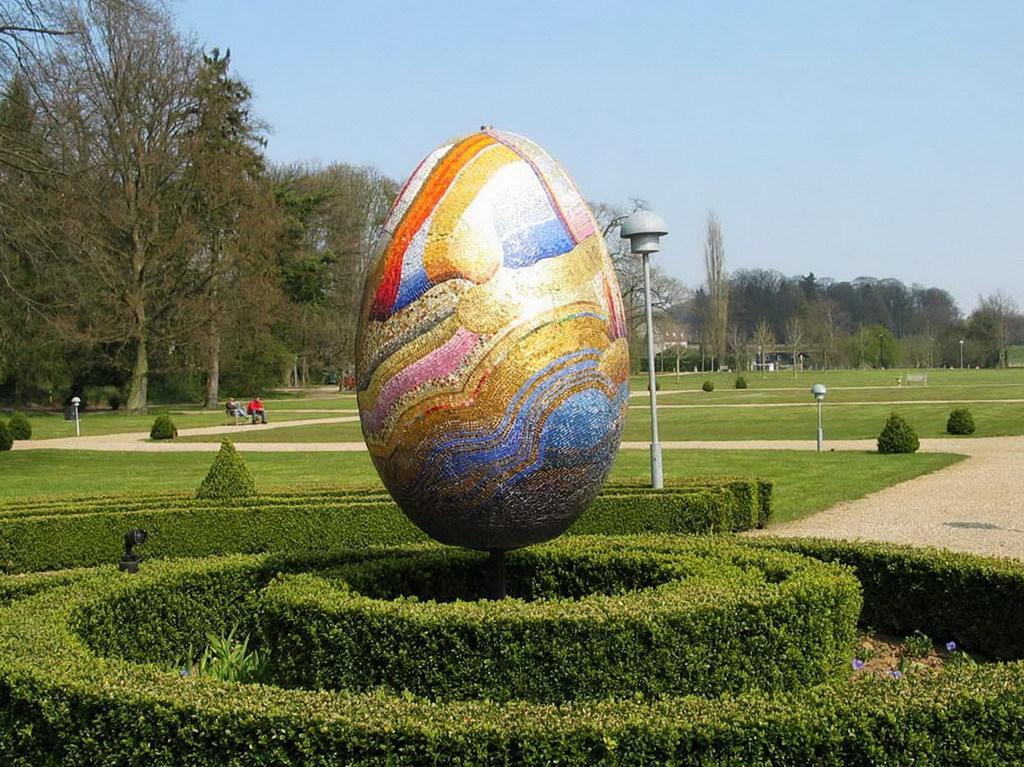Please provide a concise description of this image. In this image, there is an outside view. There is an egg shaped object in the middle of the image. There are some plants at the bottom of the image. There is a pole in between poles. In the background of the image, there are some trees and sky. 